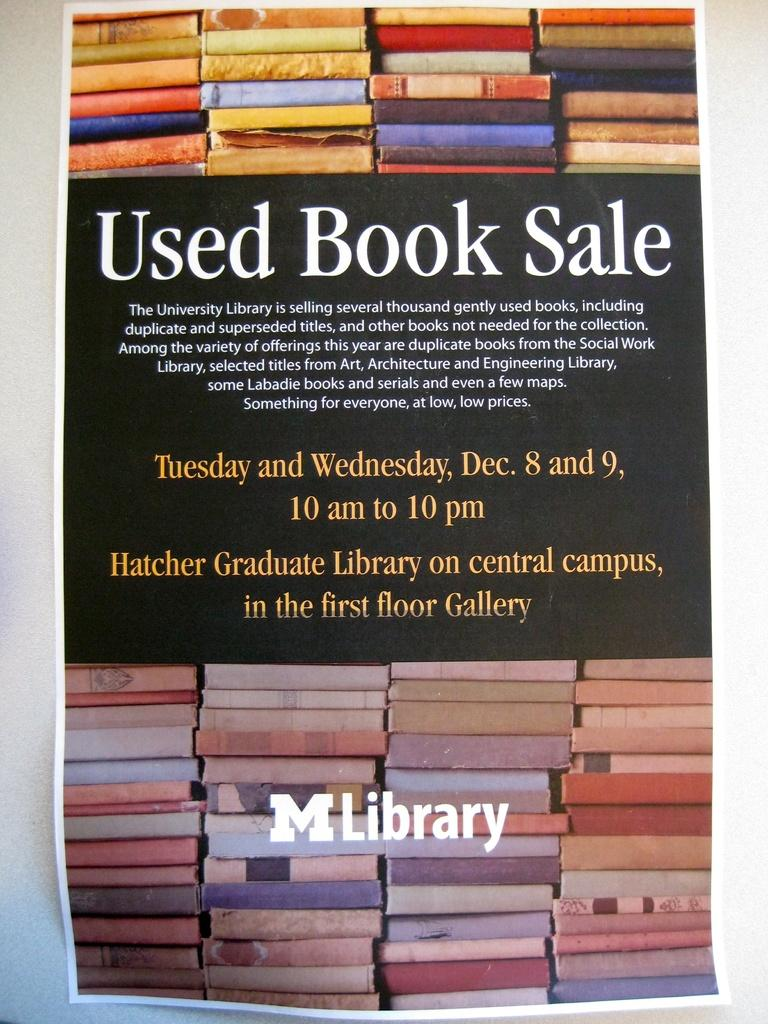<image>
Provide a brief description of the given image. An advertisement shows that there will be a used book sale. 